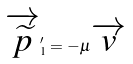Convert formula to latex. <formula><loc_0><loc_0><loc_500><loc_500>\overrightarrow { \widetilde { p } } _ { 1 } ^ { \prime } = - \mu \overrightarrow { v }</formula> 